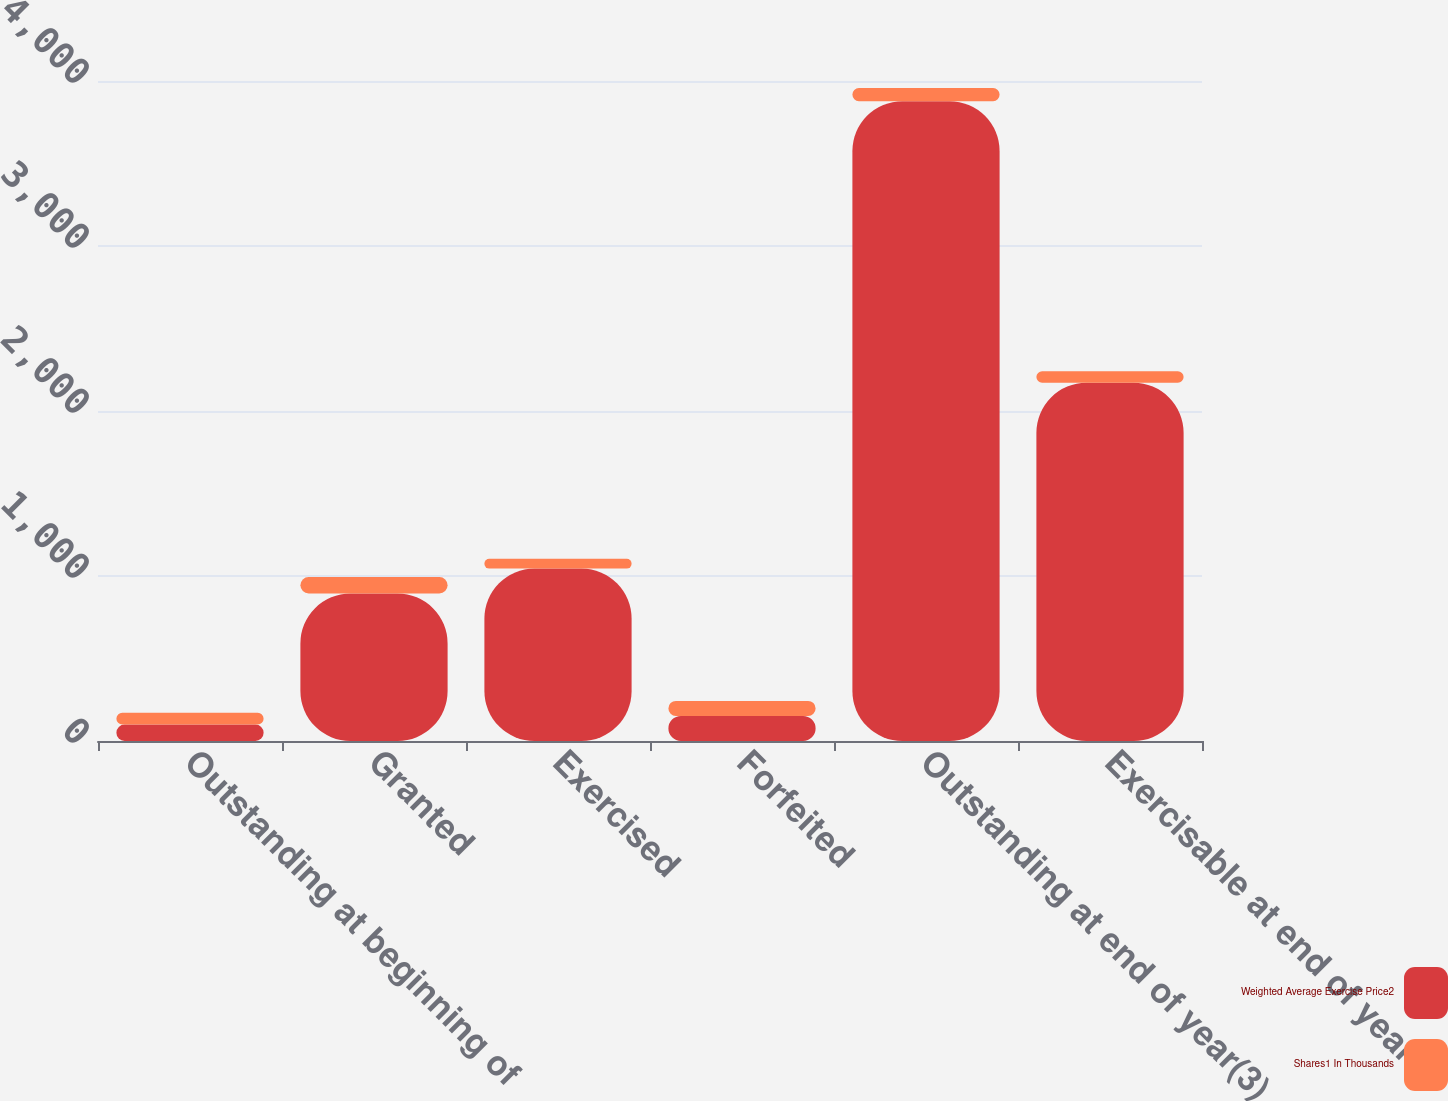Convert chart to OTSL. <chart><loc_0><loc_0><loc_500><loc_500><stacked_bar_chart><ecel><fcel>Outstanding at beginning of<fcel>Granted<fcel>Exercised<fcel>Forfeited<fcel>Outstanding at end of year(3)<fcel>Exercisable at end of year<nl><fcel>Weighted Average Exercise Price2<fcel>100<fcel>894<fcel>1045<fcel>152<fcel>3878<fcel>2171<nl><fcel>Shares1 In Thousands<fcel>71<fcel>100<fcel>59<fcel>91<fcel>79<fcel>70<nl></chart> 